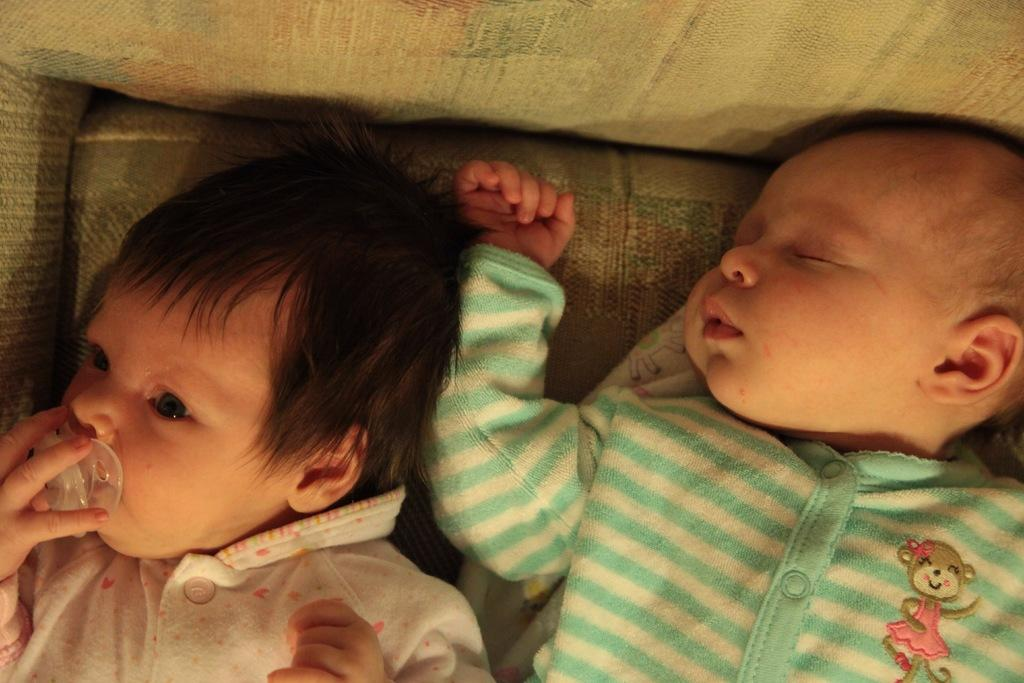How many kids are present in the image? There are two kids in the image. What is the state of one of the kids in the image? One of the kids is sleeping. What is the state of the other kid in the image? The other kid is awake. Where is the faucet located in the image? There is no faucet present in the image. What type of leaf can be seen falling from the tree in the image? There is no tree or leaf present in the image. 